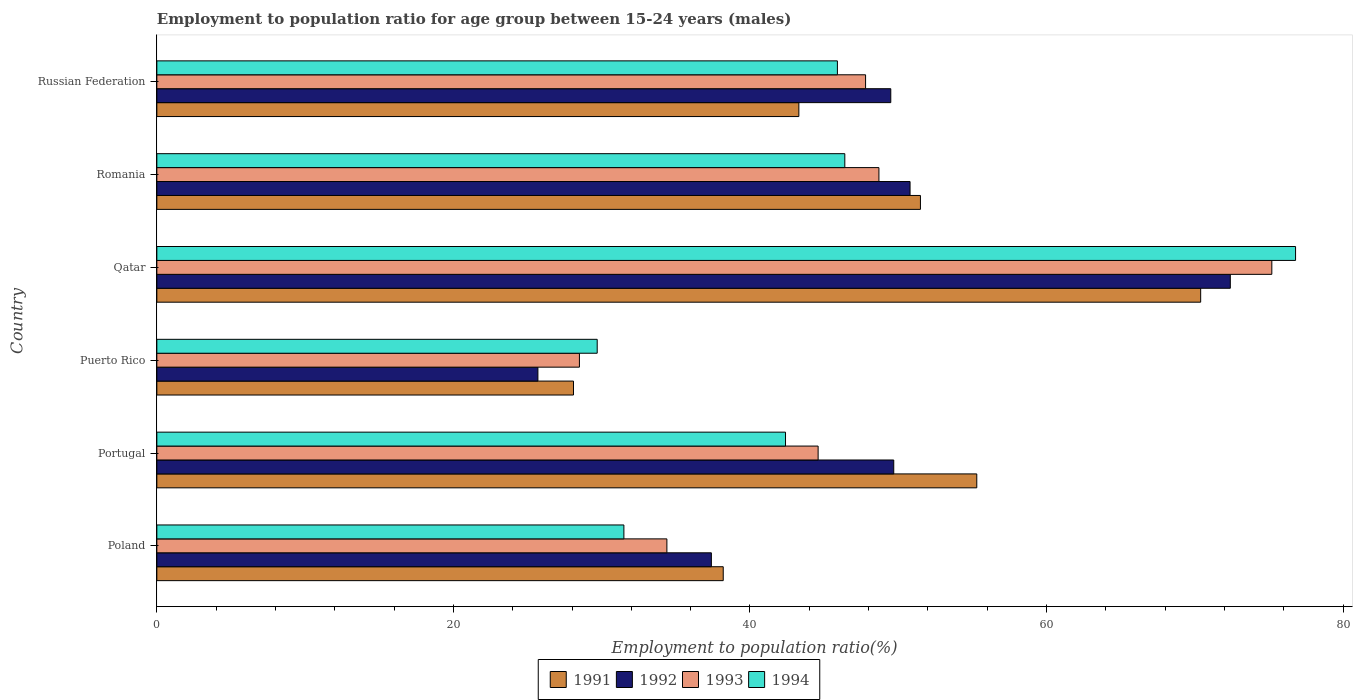Are the number of bars on each tick of the Y-axis equal?
Keep it short and to the point. Yes. How many bars are there on the 6th tick from the bottom?
Your response must be concise. 4. What is the label of the 1st group of bars from the top?
Make the answer very short. Russian Federation. In how many cases, is the number of bars for a given country not equal to the number of legend labels?
Your response must be concise. 0. What is the employment to population ratio in 1992 in Russian Federation?
Give a very brief answer. 49.5. Across all countries, what is the maximum employment to population ratio in 1992?
Offer a very short reply. 72.4. Across all countries, what is the minimum employment to population ratio in 1992?
Your answer should be very brief. 25.7. In which country was the employment to population ratio in 1994 maximum?
Your answer should be very brief. Qatar. In which country was the employment to population ratio in 1992 minimum?
Ensure brevity in your answer.  Puerto Rico. What is the total employment to population ratio in 1993 in the graph?
Provide a short and direct response. 279.2. What is the difference between the employment to population ratio in 1993 in Romania and that in Russian Federation?
Keep it short and to the point. 0.9. What is the difference between the employment to population ratio in 1994 in Russian Federation and the employment to population ratio in 1993 in Romania?
Give a very brief answer. -2.8. What is the average employment to population ratio in 1993 per country?
Offer a terse response. 46.53. What is the difference between the employment to population ratio in 1994 and employment to population ratio in 1991 in Russian Federation?
Offer a terse response. 2.6. What is the ratio of the employment to population ratio in 1993 in Portugal to that in Romania?
Your answer should be compact. 0.92. What is the difference between the highest and the second highest employment to population ratio in 1994?
Your response must be concise. 30.4. What is the difference between the highest and the lowest employment to population ratio in 1993?
Give a very brief answer. 46.7. In how many countries, is the employment to population ratio in 1991 greater than the average employment to population ratio in 1991 taken over all countries?
Offer a very short reply. 3. Is it the case that in every country, the sum of the employment to population ratio in 1994 and employment to population ratio in 1993 is greater than the employment to population ratio in 1992?
Your answer should be very brief. Yes. How many bars are there?
Offer a very short reply. 24. How many countries are there in the graph?
Provide a short and direct response. 6. What is the difference between two consecutive major ticks on the X-axis?
Make the answer very short. 20. Where does the legend appear in the graph?
Make the answer very short. Bottom center. What is the title of the graph?
Your answer should be very brief. Employment to population ratio for age group between 15-24 years (males). Does "2009" appear as one of the legend labels in the graph?
Offer a terse response. No. What is the label or title of the X-axis?
Your answer should be very brief. Employment to population ratio(%). What is the Employment to population ratio(%) in 1991 in Poland?
Provide a succinct answer. 38.2. What is the Employment to population ratio(%) in 1992 in Poland?
Provide a succinct answer. 37.4. What is the Employment to population ratio(%) of 1993 in Poland?
Offer a terse response. 34.4. What is the Employment to population ratio(%) of 1994 in Poland?
Give a very brief answer. 31.5. What is the Employment to population ratio(%) in 1991 in Portugal?
Your response must be concise. 55.3. What is the Employment to population ratio(%) in 1992 in Portugal?
Your response must be concise. 49.7. What is the Employment to population ratio(%) in 1993 in Portugal?
Your answer should be very brief. 44.6. What is the Employment to population ratio(%) of 1994 in Portugal?
Provide a short and direct response. 42.4. What is the Employment to population ratio(%) in 1991 in Puerto Rico?
Your answer should be compact. 28.1. What is the Employment to population ratio(%) of 1992 in Puerto Rico?
Your response must be concise. 25.7. What is the Employment to population ratio(%) of 1994 in Puerto Rico?
Your answer should be very brief. 29.7. What is the Employment to population ratio(%) in 1991 in Qatar?
Your answer should be compact. 70.4. What is the Employment to population ratio(%) in 1992 in Qatar?
Make the answer very short. 72.4. What is the Employment to population ratio(%) of 1993 in Qatar?
Give a very brief answer. 75.2. What is the Employment to population ratio(%) in 1994 in Qatar?
Offer a very short reply. 76.8. What is the Employment to population ratio(%) of 1991 in Romania?
Your answer should be compact. 51.5. What is the Employment to population ratio(%) in 1992 in Romania?
Give a very brief answer. 50.8. What is the Employment to population ratio(%) of 1993 in Romania?
Ensure brevity in your answer.  48.7. What is the Employment to population ratio(%) in 1994 in Romania?
Keep it short and to the point. 46.4. What is the Employment to population ratio(%) of 1991 in Russian Federation?
Give a very brief answer. 43.3. What is the Employment to population ratio(%) of 1992 in Russian Federation?
Give a very brief answer. 49.5. What is the Employment to population ratio(%) in 1993 in Russian Federation?
Keep it short and to the point. 47.8. What is the Employment to population ratio(%) in 1994 in Russian Federation?
Offer a terse response. 45.9. Across all countries, what is the maximum Employment to population ratio(%) of 1991?
Provide a short and direct response. 70.4. Across all countries, what is the maximum Employment to population ratio(%) in 1992?
Your answer should be compact. 72.4. Across all countries, what is the maximum Employment to population ratio(%) of 1993?
Make the answer very short. 75.2. Across all countries, what is the maximum Employment to population ratio(%) of 1994?
Offer a terse response. 76.8. Across all countries, what is the minimum Employment to population ratio(%) in 1991?
Your response must be concise. 28.1. Across all countries, what is the minimum Employment to population ratio(%) in 1992?
Your response must be concise. 25.7. Across all countries, what is the minimum Employment to population ratio(%) in 1994?
Your answer should be compact. 29.7. What is the total Employment to population ratio(%) in 1991 in the graph?
Your answer should be compact. 286.8. What is the total Employment to population ratio(%) of 1992 in the graph?
Your answer should be compact. 285.5. What is the total Employment to population ratio(%) of 1993 in the graph?
Your response must be concise. 279.2. What is the total Employment to population ratio(%) in 1994 in the graph?
Provide a succinct answer. 272.7. What is the difference between the Employment to population ratio(%) in 1991 in Poland and that in Portugal?
Ensure brevity in your answer.  -17.1. What is the difference between the Employment to population ratio(%) in 1994 in Poland and that in Portugal?
Provide a succinct answer. -10.9. What is the difference between the Employment to population ratio(%) in 1992 in Poland and that in Puerto Rico?
Give a very brief answer. 11.7. What is the difference between the Employment to population ratio(%) in 1993 in Poland and that in Puerto Rico?
Your answer should be very brief. 5.9. What is the difference between the Employment to population ratio(%) in 1991 in Poland and that in Qatar?
Your response must be concise. -32.2. What is the difference between the Employment to population ratio(%) of 1992 in Poland and that in Qatar?
Give a very brief answer. -35. What is the difference between the Employment to population ratio(%) in 1993 in Poland and that in Qatar?
Make the answer very short. -40.8. What is the difference between the Employment to population ratio(%) in 1994 in Poland and that in Qatar?
Provide a succinct answer. -45.3. What is the difference between the Employment to population ratio(%) in 1992 in Poland and that in Romania?
Keep it short and to the point. -13.4. What is the difference between the Employment to population ratio(%) in 1993 in Poland and that in Romania?
Offer a very short reply. -14.3. What is the difference between the Employment to population ratio(%) of 1994 in Poland and that in Romania?
Ensure brevity in your answer.  -14.9. What is the difference between the Employment to population ratio(%) in 1993 in Poland and that in Russian Federation?
Offer a terse response. -13.4. What is the difference between the Employment to population ratio(%) of 1994 in Poland and that in Russian Federation?
Provide a succinct answer. -14.4. What is the difference between the Employment to population ratio(%) of 1991 in Portugal and that in Puerto Rico?
Provide a succinct answer. 27.2. What is the difference between the Employment to population ratio(%) in 1992 in Portugal and that in Puerto Rico?
Provide a short and direct response. 24. What is the difference between the Employment to population ratio(%) in 1993 in Portugal and that in Puerto Rico?
Provide a short and direct response. 16.1. What is the difference between the Employment to population ratio(%) of 1991 in Portugal and that in Qatar?
Offer a terse response. -15.1. What is the difference between the Employment to population ratio(%) of 1992 in Portugal and that in Qatar?
Give a very brief answer. -22.7. What is the difference between the Employment to population ratio(%) in 1993 in Portugal and that in Qatar?
Give a very brief answer. -30.6. What is the difference between the Employment to population ratio(%) of 1994 in Portugal and that in Qatar?
Ensure brevity in your answer.  -34.4. What is the difference between the Employment to population ratio(%) in 1994 in Portugal and that in Romania?
Provide a succinct answer. -4. What is the difference between the Employment to population ratio(%) in 1993 in Portugal and that in Russian Federation?
Provide a short and direct response. -3.2. What is the difference between the Employment to population ratio(%) in 1994 in Portugal and that in Russian Federation?
Your answer should be compact. -3.5. What is the difference between the Employment to population ratio(%) of 1991 in Puerto Rico and that in Qatar?
Your answer should be compact. -42.3. What is the difference between the Employment to population ratio(%) in 1992 in Puerto Rico and that in Qatar?
Make the answer very short. -46.7. What is the difference between the Employment to population ratio(%) in 1993 in Puerto Rico and that in Qatar?
Your response must be concise. -46.7. What is the difference between the Employment to population ratio(%) in 1994 in Puerto Rico and that in Qatar?
Offer a very short reply. -47.1. What is the difference between the Employment to population ratio(%) of 1991 in Puerto Rico and that in Romania?
Your answer should be very brief. -23.4. What is the difference between the Employment to population ratio(%) of 1992 in Puerto Rico and that in Romania?
Offer a terse response. -25.1. What is the difference between the Employment to population ratio(%) of 1993 in Puerto Rico and that in Romania?
Offer a terse response. -20.2. What is the difference between the Employment to population ratio(%) of 1994 in Puerto Rico and that in Romania?
Make the answer very short. -16.7. What is the difference between the Employment to population ratio(%) in 1991 in Puerto Rico and that in Russian Federation?
Keep it short and to the point. -15.2. What is the difference between the Employment to population ratio(%) of 1992 in Puerto Rico and that in Russian Federation?
Provide a short and direct response. -23.8. What is the difference between the Employment to population ratio(%) in 1993 in Puerto Rico and that in Russian Federation?
Provide a short and direct response. -19.3. What is the difference between the Employment to population ratio(%) of 1994 in Puerto Rico and that in Russian Federation?
Ensure brevity in your answer.  -16.2. What is the difference between the Employment to population ratio(%) of 1992 in Qatar and that in Romania?
Provide a succinct answer. 21.6. What is the difference between the Employment to population ratio(%) of 1993 in Qatar and that in Romania?
Offer a very short reply. 26.5. What is the difference between the Employment to population ratio(%) of 1994 in Qatar and that in Romania?
Keep it short and to the point. 30.4. What is the difference between the Employment to population ratio(%) of 1991 in Qatar and that in Russian Federation?
Provide a short and direct response. 27.1. What is the difference between the Employment to population ratio(%) in 1992 in Qatar and that in Russian Federation?
Ensure brevity in your answer.  22.9. What is the difference between the Employment to population ratio(%) in 1993 in Qatar and that in Russian Federation?
Offer a terse response. 27.4. What is the difference between the Employment to population ratio(%) of 1994 in Qatar and that in Russian Federation?
Offer a very short reply. 30.9. What is the difference between the Employment to population ratio(%) in 1992 in Romania and that in Russian Federation?
Ensure brevity in your answer.  1.3. What is the difference between the Employment to population ratio(%) in 1993 in Romania and that in Russian Federation?
Make the answer very short. 0.9. What is the difference between the Employment to population ratio(%) in 1994 in Romania and that in Russian Federation?
Your answer should be very brief. 0.5. What is the difference between the Employment to population ratio(%) in 1991 in Poland and the Employment to population ratio(%) in 1992 in Portugal?
Provide a succinct answer. -11.5. What is the difference between the Employment to population ratio(%) in 1991 in Poland and the Employment to population ratio(%) in 1993 in Portugal?
Keep it short and to the point. -6.4. What is the difference between the Employment to population ratio(%) of 1991 in Poland and the Employment to population ratio(%) of 1994 in Portugal?
Offer a very short reply. -4.2. What is the difference between the Employment to population ratio(%) in 1992 in Poland and the Employment to population ratio(%) in 1994 in Portugal?
Keep it short and to the point. -5. What is the difference between the Employment to population ratio(%) in 1991 in Poland and the Employment to population ratio(%) in 1992 in Puerto Rico?
Provide a succinct answer. 12.5. What is the difference between the Employment to population ratio(%) in 1991 in Poland and the Employment to population ratio(%) in 1992 in Qatar?
Provide a short and direct response. -34.2. What is the difference between the Employment to population ratio(%) in 1991 in Poland and the Employment to population ratio(%) in 1993 in Qatar?
Your answer should be very brief. -37. What is the difference between the Employment to population ratio(%) in 1991 in Poland and the Employment to population ratio(%) in 1994 in Qatar?
Make the answer very short. -38.6. What is the difference between the Employment to population ratio(%) in 1992 in Poland and the Employment to population ratio(%) in 1993 in Qatar?
Ensure brevity in your answer.  -37.8. What is the difference between the Employment to population ratio(%) in 1992 in Poland and the Employment to population ratio(%) in 1994 in Qatar?
Your answer should be compact. -39.4. What is the difference between the Employment to population ratio(%) of 1993 in Poland and the Employment to population ratio(%) of 1994 in Qatar?
Keep it short and to the point. -42.4. What is the difference between the Employment to population ratio(%) of 1991 in Poland and the Employment to population ratio(%) of 1993 in Romania?
Provide a succinct answer. -10.5. What is the difference between the Employment to population ratio(%) of 1991 in Poland and the Employment to population ratio(%) of 1994 in Romania?
Provide a succinct answer. -8.2. What is the difference between the Employment to population ratio(%) of 1992 in Poland and the Employment to population ratio(%) of 1994 in Romania?
Offer a terse response. -9. What is the difference between the Employment to population ratio(%) in 1991 in Poland and the Employment to population ratio(%) in 1992 in Russian Federation?
Offer a terse response. -11.3. What is the difference between the Employment to population ratio(%) in 1992 in Poland and the Employment to population ratio(%) in 1993 in Russian Federation?
Offer a very short reply. -10.4. What is the difference between the Employment to population ratio(%) in 1993 in Poland and the Employment to population ratio(%) in 1994 in Russian Federation?
Ensure brevity in your answer.  -11.5. What is the difference between the Employment to population ratio(%) of 1991 in Portugal and the Employment to population ratio(%) of 1992 in Puerto Rico?
Provide a succinct answer. 29.6. What is the difference between the Employment to population ratio(%) in 1991 in Portugal and the Employment to population ratio(%) in 1993 in Puerto Rico?
Your response must be concise. 26.8. What is the difference between the Employment to population ratio(%) of 1991 in Portugal and the Employment to population ratio(%) of 1994 in Puerto Rico?
Offer a very short reply. 25.6. What is the difference between the Employment to population ratio(%) in 1992 in Portugal and the Employment to population ratio(%) in 1993 in Puerto Rico?
Give a very brief answer. 21.2. What is the difference between the Employment to population ratio(%) of 1992 in Portugal and the Employment to population ratio(%) of 1994 in Puerto Rico?
Give a very brief answer. 20. What is the difference between the Employment to population ratio(%) of 1993 in Portugal and the Employment to population ratio(%) of 1994 in Puerto Rico?
Offer a very short reply. 14.9. What is the difference between the Employment to population ratio(%) of 1991 in Portugal and the Employment to population ratio(%) of 1992 in Qatar?
Your answer should be very brief. -17.1. What is the difference between the Employment to population ratio(%) in 1991 in Portugal and the Employment to population ratio(%) in 1993 in Qatar?
Give a very brief answer. -19.9. What is the difference between the Employment to population ratio(%) in 1991 in Portugal and the Employment to population ratio(%) in 1994 in Qatar?
Offer a very short reply. -21.5. What is the difference between the Employment to population ratio(%) in 1992 in Portugal and the Employment to population ratio(%) in 1993 in Qatar?
Keep it short and to the point. -25.5. What is the difference between the Employment to population ratio(%) in 1992 in Portugal and the Employment to population ratio(%) in 1994 in Qatar?
Ensure brevity in your answer.  -27.1. What is the difference between the Employment to population ratio(%) in 1993 in Portugal and the Employment to population ratio(%) in 1994 in Qatar?
Make the answer very short. -32.2. What is the difference between the Employment to population ratio(%) of 1991 in Portugal and the Employment to population ratio(%) of 1993 in Romania?
Your answer should be very brief. 6.6. What is the difference between the Employment to population ratio(%) of 1991 in Portugal and the Employment to population ratio(%) of 1994 in Romania?
Offer a very short reply. 8.9. What is the difference between the Employment to population ratio(%) in 1993 in Portugal and the Employment to population ratio(%) in 1994 in Romania?
Offer a terse response. -1.8. What is the difference between the Employment to population ratio(%) of 1991 in Portugal and the Employment to population ratio(%) of 1993 in Russian Federation?
Your answer should be compact. 7.5. What is the difference between the Employment to population ratio(%) of 1991 in Portugal and the Employment to population ratio(%) of 1994 in Russian Federation?
Make the answer very short. 9.4. What is the difference between the Employment to population ratio(%) in 1992 in Portugal and the Employment to population ratio(%) in 1993 in Russian Federation?
Your response must be concise. 1.9. What is the difference between the Employment to population ratio(%) of 1991 in Puerto Rico and the Employment to population ratio(%) of 1992 in Qatar?
Ensure brevity in your answer.  -44.3. What is the difference between the Employment to population ratio(%) in 1991 in Puerto Rico and the Employment to population ratio(%) in 1993 in Qatar?
Provide a succinct answer. -47.1. What is the difference between the Employment to population ratio(%) in 1991 in Puerto Rico and the Employment to population ratio(%) in 1994 in Qatar?
Make the answer very short. -48.7. What is the difference between the Employment to population ratio(%) of 1992 in Puerto Rico and the Employment to population ratio(%) of 1993 in Qatar?
Your response must be concise. -49.5. What is the difference between the Employment to population ratio(%) of 1992 in Puerto Rico and the Employment to population ratio(%) of 1994 in Qatar?
Your answer should be compact. -51.1. What is the difference between the Employment to population ratio(%) of 1993 in Puerto Rico and the Employment to population ratio(%) of 1994 in Qatar?
Provide a short and direct response. -48.3. What is the difference between the Employment to population ratio(%) in 1991 in Puerto Rico and the Employment to population ratio(%) in 1992 in Romania?
Offer a terse response. -22.7. What is the difference between the Employment to population ratio(%) of 1991 in Puerto Rico and the Employment to population ratio(%) of 1993 in Romania?
Offer a terse response. -20.6. What is the difference between the Employment to population ratio(%) of 1991 in Puerto Rico and the Employment to population ratio(%) of 1994 in Romania?
Offer a very short reply. -18.3. What is the difference between the Employment to population ratio(%) in 1992 in Puerto Rico and the Employment to population ratio(%) in 1994 in Romania?
Offer a terse response. -20.7. What is the difference between the Employment to population ratio(%) in 1993 in Puerto Rico and the Employment to population ratio(%) in 1994 in Romania?
Provide a short and direct response. -17.9. What is the difference between the Employment to population ratio(%) of 1991 in Puerto Rico and the Employment to population ratio(%) of 1992 in Russian Federation?
Keep it short and to the point. -21.4. What is the difference between the Employment to population ratio(%) in 1991 in Puerto Rico and the Employment to population ratio(%) in 1993 in Russian Federation?
Offer a terse response. -19.7. What is the difference between the Employment to population ratio(%) of 1991 in Puerto Rico and the Employment to population ratio(%) of 1994 in Russian Federation?
Your response must be concise. -17.8. What is the difference between the Employment to population ratio(%) of 1992 in Puerto Rico and the Employment to population ratio(%) of 1993 in Russian Federation?
Offer a terse response. -22.1. What is the difference between the Employment to population ratio(%) in 1992 in Puerto Rico and the Employment to population ratio(%) in 1994 in Russian Federation?
Provide a short and direct response. -20.2. What is the difference between the Employment to population ratio(%) in 1993 in Puerto Rico and the Employment to population ratio(%) in 1994 in Russian Federation?
Your response must be concise. -17.4. What is the difference between the Employment to population ratio(%) in 1991 in Qatar and the Employment to population ratio(%) in 1992 in Romania?
Offer a very short reply. 19.6. What is the difference between the Employment to population ratio(%) in 1991 in Qatar and the Employment to population ratio(%) in 1993 in Romania?
Provide a succinct answer. 21.7. What is the difference between the Employment to population ratio(%) of 1991 in Qatar and the Employment to population ratio(%) of 1994 in Romania?
Provide a succinct answer. 24. What is the difference between the Employment to population ratio(%) of 1992 in Qatar and the Employment to population ratio(%) of 1993 in Romania?
Make the answer very short. 23.7. What is the difference between the Employment to population ratio(%) in 1993 in Qatar and the Employment to population ratio(%) in 1994 in Romania?
Your response must be concise. 28.8. What is the difference between the Employment to population ratio(%) of 1991 in Qatar and the Employment to population ratio(%) of 1992 in Russian Federation?
Provide a short and direct response. 20.9. What is the difference between the Employment to population ratio(%) in 1991 in Qatar and the Employment to population ratio(%) in 1993 in Russian Federation?
Offer a terse response. 22.6. What is the difference between the Employment to population ratio(%) of 1992 in Qatar and the Employment to population ratio(%) of 1993 in Russian Federation?
Provide a succinct answer. 24.6. What is the difference between the Employment to population ratio(%) in 1993 in Qatar and the Employment to population ratio(%) in 1994 in Russian Federation?
Your response must be concise. 29.3. What is the difference between the Employment to population ratio(%) in 1991 in Romania and the Employment to population ratio(%) in 1992 in Russian Federation?
Your answer should be compact. 2. What is the difference between the Employment to population ratio(%) of 1991 in Romania and the Employment to population ratio(%) of 1993 in Russian Federation?
Ensure brevity in your answer.  3.7. What is the difference between the Employment to population ratio(%) of 1992 in Romania and the Employment to population ratio(%) of 1993 in Russian Federation?
Make the answer very short. 3. What is the difference between the Employment to population ratio(%) of 1993 in Romania and the Employment to population ratio(%) of 1994 in Russian Federation?
Make the answer very short. 2.8. What is the average Employment to population ratio(%) in 1991 per country?
Keep it short and to the point. 47.8. What is the average Employment to population ratio(%) in 1992 per country?
Ensure brevity in your answer.  47.58. What is the average Employment to population ratio(%) of 1993 per country?
Offer a terse response. 46.53. What is the average Employment to population ratio(%) of 1994 per country?
Keep it short and to the point. 45.45. What is the difference between the Employment to population ratio(%) in 1992 and Employment to population ratio(%) in 1993 in Poland?
Keep it short and to the point. 3. What is the difference between the Employment to population ratio(%) in 1992 and Employment to population ratio(%) in 1994 in Poland?
Make the answer very short. 5.9. What is the difference between the Employment to population ratio(%) of 1993 and Employment to population ratio(%) of 1994 in Poland?
Your answer should be very brief. 2.9. What is the difference between the Employment to population ratio(%) in 1991 and Employment to population ratio(%) in 1992 in Portugal?
Provide a short and direct response. 5.6. What is the difference between the Employment to population ratio(%) in 1991 and Employment to population ratio(%) in 1994 in Portugal?
Provide a succinct answer. 12.9. What is the difference between the Employment to population ratio(%) in 1992 and Employment to population ratio(%) in 1993 in Portugal?
Give a very brief answer. 5.1. What is the difference between the Employment to population ratio(%) in 1991 and Employment to population ratio(%) in 1992 in Puerto Rico?
Keep it short and to the point. 2.4. What is the difference between the Employment to population ratio(%) of 1991 and Employment to population ratio(%) of 1993 in Puerto Rico?
Offer a very short reply. -0.4. What is the difference between the Employment to population ratio(%) of 1991 and Employment to population ratio(%) of 1994 in Puerto Rico?
Keep it short and to the point. -1.6. What is the difference between the Employment to population ratio(%) in 1992 and Employment to population ratio(%) in 1993 in Puerto Rico?
Provide a succinct answer. -2.8. What is the difference between the Employment to population ratio(%) in 1993 and Employment to population ratio(%) in 1994 in Puerto Rico?
Give a very brief answer. -1.2. What is the difference between the Employment to population ratio(%) in 1991 and Employment to population ratio(%) in 1992 in Qatar?
Provide a short and direct response. -2. What is the difference between the Employment to population ratio(%) in 1991 and Employment to population ratio(%) in 1993 in Qatar?
Your response must be concise. -4.8. What is the difference between the Employment to population ratio(%) in 1991 and Employment to population ratio(%) in 1994 in Qatar?
Keep it short and to the point. -6.4. What is the difference between the Employment to population ratio(%) in 1992 and Employment to population ratio(%) in 1994 in Qatar?
Offer a terse response. -4.4. What is the difference between the Employment to population ratio(%) of 1993 and Employment to population ratio(%) of 1994 in Qatar?
Make the answer very short. -1.6. What is the difference between the Employment to population ratio(%) of 1991 and Employment to population ratio(%) of 1992 in Romania?
Offer a very short reply. 0.7. What is the difference between the Employment to population ratio(%) in 1992 and Employment to population ratio(%) in 1993 in Romania?
Your response must be concise. 2.1. What is the difference between the Employment to population ratio(%) in 1992 and Employment to population ratio(%) in 1994 in Romania?
Give a very brief answer. 4.4. What is the difference between the Employment to population ratio(%) in 1993 and Employment to population ratio(%) in 1994 in Romania?
Ensure brevity in your answer.  2.3. What is the difference between the Employment to population ratio(%) in 1991 and Employment to population ratio(%) in 1992 in Russian Federation?
Your response must be concise. -6.2. What is the difference between the Employment to population ratio(%) in 1991 and Employment to population ratio(%) in 1994 in Russian Federation?
Offer a terse response. -2.6. What is the difference between the Employment to population ratio(%) in 1992 and Employment to population ratio(%) in 1993 in Russian Federation?
Ensure brevity in your answer.  1.7. What is the ratio of the Employment to population ratio(%) of 1991 in Poland to that in Portugal?
Provide a succinct answer. 0.69. What is the ratio of the Employment to population ratio(%) of 1992 in Poland to that in Portugal?
Provide a succinct answer. 0.75. What is the ratio of the Employment to population ratio(%) of 1993 in Poland to that in Portugal?
Your answer should be very brief. 0.77. What is the ratio of the Employment to population ratio(%) in 1994 in Poland to that in Portugal?
Offer a very short reply. 0.74. What is the ratio of the Employment to population ratio(%) of 1991 in Poland to that in Puerto Rico?
Make the answer very short. 1.36. What is the ratio of the Employment to population ratio(%) of 1992 in Poland to that in Puerto Rico?
Provide a short and direct response. 1.46. What is the ratio of the Employment to population ratio(%) of 1993 in Poland to that in Puerto Rico?
Your answer should be very brief. 1.21. What is the ratio of the Employment to population ratio(%) of 1994 in Poland to that in Puerto Rico?
Your answer should be compact. 1.06. What is the ratio of the Employment to population ratio(%) of 1991 in Poland to that in Qatar?
Make the answer very short. 0.54. What is the ratio of the Employment to population ratio(%) of 1992 in Poland to that in Qatar?
Offer a very short reply. 0.52. What is the ratio of the Employment to population ratio(%) of 1993 in Poland to that in Qatar?
Keep it short and to the point. 0.46. What is the ratio of the Employment to population ratio(%) in 1994 in Poland to that in Qatar?
Give a very brief answer. 0.41. What is the ratio of the Employment to population ratio(%) in 1991 in Poland to that in Romania?
Keep it short and to the point. 0.74. What is the ratio of the Employment to population ratio(%) of 1992 in Poland to that in Romania?
Your answer should be compact. 0.74. What is the ratio of the Employment to population ratio(%) of 1993 in Poland to that in Romania?
Offer a terse response. 0.71. What is the ratio of the Employment to population ratio(%) of 1994 in Poland to that in Romania?
Give a very brief answer. 0.68. What is the ratio of the Employment to population ratio(%) of 1991 in Poland to that in Russian Federation?
Make the answer very short. 0.88. What is the ratio of the Employment to population ratio(%) of 1992 in Poland to that in Russian Federation?
Offer a very short reply. 0.76. What is the ratio of the Employment to population ratio(%) in 1993 in Poland to that in Russian Federation?
Give a very brief answer. 0.72. What is the ratio of the Employment to population ratio(%) in 1994 in Poland to that in Russian Federation?
Provide a succinct answer. 0.69. What is the ratio of the Employment to population ratio(%) of 1991 in Portugal to that in Puerto Rico?
Make the answer very short. 1.97. What is the ratio of the Employment to population ratio(%) of 1992 in Portugal to that in Puerto Rico?
Provide a succinct answer. 1.93. What is the ratio of the Employment to population ratio(%) of 1993 in Portugal to that in Puerto Rico?
Give a very brief answer. 1.56. What is the ratio of the Employment to population ratio(%) of 1994 in Portugal to that in Puerto Rico?
Your response must be concise. 1.43. What is the ratio of the Employment to population ratio(%) in 1991 in Portugal to that in Qatar?
Your answer should be compact. 0.79. What is the ratio of the Employment to population ratio(%) of 1992 in Portugal to that in Qatar?
Your answer should be very brief. 0.69. What is the ratio of the Employment to population ratio(%) in 1993 in Portugal to that in Qatar?
Your response must be concise. 0.59. What is the ratio of the Employment to population ratio(%) of 1994 in Portugal to that in Qatar?
Your answer should be very brief. 0.55. What is the ratio of the Employment to population ratio(%) of 1991 in Portugal to that in Romania?
Offer a very short reply. 1.07. What is the ratio of the Employment to population ratio(%) of 1992 in Portugal to that in Romania?
Give a very brief answer. 0.98. What is the ratio of the Employment to population ratio(%) in 1993 in Portugal to that in Romania?
Your answer should be compact. 0.92. What is the ratio of the Employment to population ratio(%) in 1994 in Portugal to that in Romania?
Ensure brevity in your answer.  0.91. What is the ratio of the Employment to population ratio(%) of 1991 in Portugal to that in Russian Federation?
Make the answer very short. 1.28. What is the ratio of the Employment to population ratio(%) of 1992 in Portugal to that in Russian Federation?
Offer a terse response. 1. What is the ratio of the Employment to population ratio(%) of 1993 in Portugal to that in Russian Federation?
Your answer should be very brief. 0.93. What is the ratio of the Employment to population ratio(%) in 1994 in Portugal to that in Russian Federation?
Offer a very short reply. 0.92. What is the ratio of the Employment to population ratio(%) in 1991 in Puerto Rico to that in Qatar?
Offer a very short reply. 0.4. What is the ratio of the Employment to population ratio(%) in 1992 in Puerto Rico to that in Qatar?
Ensure brevity in your answer.  0.35. What is the ratio of the Employment to population ratio(%) in 1993 in Puerto Rico to that in Qatar?
Offer a very short reply. 0.38. What is the ratio of the Employment to population ratio(%) in 1994 in Puerto Rico to that in Qatar?
Ensure brevity in your answer.  0.39. What is the ratio of the Employment to population ratio(%) in 1991 in Puerto Rico to that in Romania?
Provide a succinct answer. 0.55. What is the ratio of the Employment to population ratio(%) of 1992 in Puerto Rico to that in Romania?
Ensure brevity in your answer.  0.51. What is the ratio of the Employment to population ratio(%) in 1993 in Puerto Rico to that in Romania?
Give a very brief answer. 0.59. What is the ratio of the Employment to population ratio(%) in 1994 in Puerto Rico to that in Romania?
Your answer should be very brief. 0.64. What is the ratio of the Employment to population ratio(%) of 1991 in Puerto Rico to that in Russian Federation?
Offer a terse response. 0.65. What is the ratio of the Employment to population ratio(%) in 1992 in Puerto Rico to that in Russian Federation?
Provide a succinct answer. 0.52. What is the ratio of the Employment to population ratio(%) in 1993 in Puerto Rico to that in Russian Federation?
Provide a succinct answer. 0.6. What is the ratio of the Employment to population ratio(%) in 1994 in Puerto Rico to that in Russian Federation?
Offer a terse response. 0.65. What is the ratio of the Employment to population ratio(%) in 1991 in Qatar to that in Romania?
Your answer should be compact. 1.37. What is the ratio of the Employment to population ratio(%) of 1992 in Qatar to that in Romania?
Offer a very short reply. 1.43. What is the ratio of the Employment to population ratio(%) of 1993 in Qatar to that in Romania?
Provide a succinct answer. 1.54. What is the ratio of the Employment to population ratio(%) of 1994 in Qatar to that in Romania?
Make the answer very short. 1.66. What is the ratio of the Employment to population ratio(%) of 1991 in Qatar to that in Russian Federation?
Offer a very short reply. 1.63. What is the ratio of the Employment to population ratio(%) in 1992 in Qatar to that in Russian Federation?
Keep it short and to the point. 1.46. What is the ratio of the Employment to population ratio(%) in 1993 in Qatar to that in Russian Federation?
Ensure brevity in your answer.  1.57. What is the ratio of the Employment to population ratio(%) of 1994 in Qatar to that in Russian Federation?
Keep it short and to the point. 1.67. What is the ratio of the Employment to population ratio(%) of 1991 in Romania to that in Russian Federation?
Your answer should be very brief. 1.19. What is the ratio of the Employment to population ratio(%) in 1992 in Romania to that in Russian Federation?
Offer a terse response. 1.03. What is the ratio of the Employment to population ratio(%) in 1993 in Romania to that in Russian Federation?
Offer a very short reply. 1.02. What is the ratio of the Employment to population ratio(%) of 1994 in Romania to that in Russian Federation?
Make the answer very short. 1.01. What is the difference between the highest and the second highest Employment to population ratio(%) in 1991?
Provide a succinct answer. 15.1. What is the difference between the highest and the second highest Employment to population ratio(%) of 1992?
Offer a terse response. 21.6. What is the difference between the highest and the second highest Employment to population ratio(%) in 1994?
Offer a very short reply. 30.4. What is the difference between the highest and the lowest Employment to population ratio(%) in 1991?
Make the answer very short. 42.3. What is the difference between the highest and the lowest Employment to population ratio(%) of 1992?
Offer a very short reply. 46.7. What is the difference between the highest and the lowest Employment to population ratio(%) in 1993?
Your answer should be very brief. 46.7. What is the difference between the highest and the lowest Employment to population ratio(%) of 1994?
Keep it short and to the point. 47.1. 